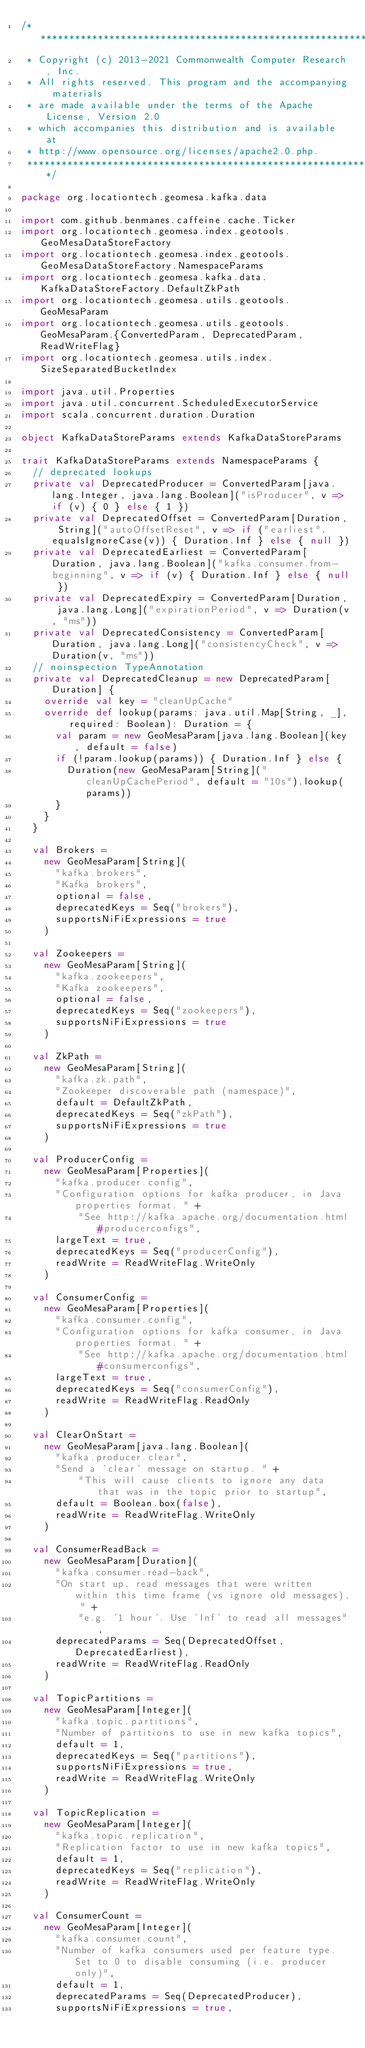Convert code to text. <code><loc_0><loc_0><loc_500><loc_500><_Scala_>/***********************************************************************
 * Copyright (c) 2013-2021 Commonwealth Computer Research, Inc.
 * All rights reserved. This program and the accompanying materials
 * are made available under the terms of the Apache License, Version 2.0
 * which accompanies this distribution and is available at
 * http://www.opensource.org/licenses/apache2.0.php.
 ***********************************************************************/

package org.locationtech.geomesa.kafka.data

import com.github.benmanes.caffeine.cache.Ticker
import org.locationtech.geomesa.index.geotools.GeoMesaDataStoreFactory
import org.locationtech.geomesa.index.geotools.GeoMesaDataStoreFactory.NamespaceParams
import org.locationtech.geomesa.kafka.data.KafkaDataStoreFactory.DefaultZkPath
import org.locationtech.geomesa.utils.geotools.GeoMesaParam
import org.locationtech.geomesa.utils.geotools.GeoMesaParam.{ConvertedParam, DeprecatedParam, ReadWriteFlag}
import org.locationtech.geomesa.utils.index.SizeSeparatedBucketIndex

import java.util.Properties
import java.util.concurrent.ScheduledExecutorService
import scala.concurrent.duration.Duration

object KafkaDataStoreParams extends KafkaDataStoreParams

trait KafkaDataStoreParams extends NamespaceParams {
  // deprecated lookups
  private val DeprecatedProducer = ConvertedParam[java.lang.Integer, java.lang.Boolean]("isProducer", v => if (v) { 0 } else { 1 })
  private val DeprecatedOffset = ConvertedParam[Duration, String]("autoOffsetReset", v => if ("earliest".equalsIgnoreCase(v)) { Duration.Inf } else { null })
  private val DeprecatedEarliest = ConvertedParam[Duration, java.lang.Boolean]("kafka.consumer.from-beginning", v => if (v) { Duration.Inf } else { null })
  private val DeprecatedExpiry = ConvertedParam[Duration, java.lang.Long]("expirationPeriod", v => Duration(v, "ms"))
  private val DeprecatedConsistency = ConvertedParam[Duration, java.lang.Long]("consistencyCheck", v => Duration(v, "ms"))
  // noinspection TypeAnnotation
  private val DeprecatedCleanup = new DeprecatedParam[Duration] {
    override val key = "cleanUpCache"
    override def lookup(params: java.util.Map[String, _], required: Boolean): Duration = {
      val param = new GeoMesaParam[java.lang.Boolean](key, default = false)
      if (!param.lookup(params)) { Duration.Inf } else {
        Duration(new GeoMesaParam[String]("cleanUpCachePeriod", default = "10s").lookup(params))
      }
    }
  }

  val Brokers =
    new GeoMesaParam[String](
      "kafka.brokers",
      "Kafka brokers",
      optional = false,
      deprecatedKeys = Seq("brokers"),
      supportsNiFiExpressions = true
    )

  val Zookeepers =
    new GeoMesaParam[String](
      "kafka.zookeepers",
      "Kafka zookeepers",
      optional = false,
      deprecatedKeys = Seq("zookeepers"),
      supportsNiFiExpressions = true
    )

  val ZkPath =
    new GeoMesaParam[String](
      "kafka.zk.path",
      "Zookeeper discoverable path (namespace)",
      default = DefaultZkPath,
      deprecatedKeys = Seq("zkPath"),
      supportsNiFiExpressions = true
    )

  val ProducerConfig =
    new GeoMesaParam[Properties](
      "kafka.producer.config",
      "Configuration options for kafka producer, in Java properties format. " +
          "See http://kafka.apache.org/documentation.html#producerconfigs",
      largeText = true,
      deprecatedKeys = Seq("producerConfig"),
      readWrite = ReadWriteFlag.WriteOnly
    )

  val ConsumerConfig =
    new GeoMesaParam[Properties](
      "kafka.consumer.config",
      "Configuration options for kafka consumer, in Java properties format. " +
          "See http://kafka.apache.org/documentation.html#consumerconfigs",
      largeText = true,
      deprecatedKeys = Seq("consumerConfig"),
      readWrite = ReadWriteFlag.ReadOnly
    )

  val ClearOnStart =
    new GeoMesaParam[java.lang.Boolean](
      "kafka.producer.clear",
      "Send a 'clear' message on startup. " +
          "This will cause clients to ignore any data that was in the topic prior to startup",
      default = Boolean.box(false),
      readWrite = ReadWriteFlag.WriteOnly
    )

  val ConsumerReadBack =
    new GeoMesaParam[Duration](
      "kafka.consumer.read-back",
      "On start up, read messages that were written within this time frame (vs ignore old messages), " +
          "e.g. '1 hour'. Use 'Inf' to read all messages",
      deprecatedParams = Seq(DeprecatedOffset, DeprecatedEarliest),
      readWrite = ReadWriteFlag.ReadOnly
    )

  val TopicPartitions =
    new GeoMesaParam[Integer](
      "kafka.topic.partitions",
      "Number of partitions to use in new kafka topics",
      default = 1,
      deprecatedKeys = Seq("partitions"),
      supportsNiFiExpressions = true,
      readWrite = ReadWriteFlag.WriteOnly
    )

  val TopicReplication =
    new GeoMesaParam[Integer](
      "kafka.topic.replication",
      "Replication factor to use in new kafka topics",
      default = 1,
      deprecatedKeys = Seq("replication"),
      readWrite = ReadWriteFlag.WriteOnly
    )

  val ConsumerCount =
    new GeoMesaParam[Integer](
      "kafka.consumer.count",
      "Number of kafka consumers used per feature type. Set to 0 to disable consuming (i.e. producer only)",
      default = 1,
      deprecatedParams = Seq(DeprecatedProducer),
      supportsNiFiExpressions = true,</code> 